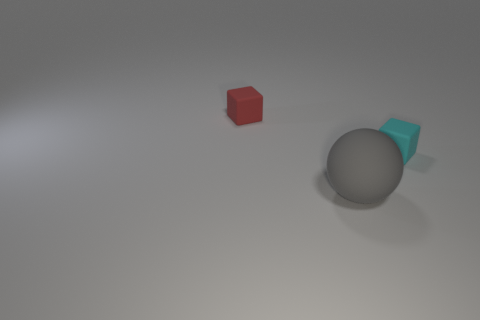Could you describe the texture and color of the objects present in the image? Certainly, there are three objects in the image. On the left, there is a small red cube with a matte finish. In the center, there's a large grey sphere that also has a matte texture. To the right of the sphere, there's a smaller cyan-colored object, possibly another cube or a rectangular shape, with a matte finish as well. 